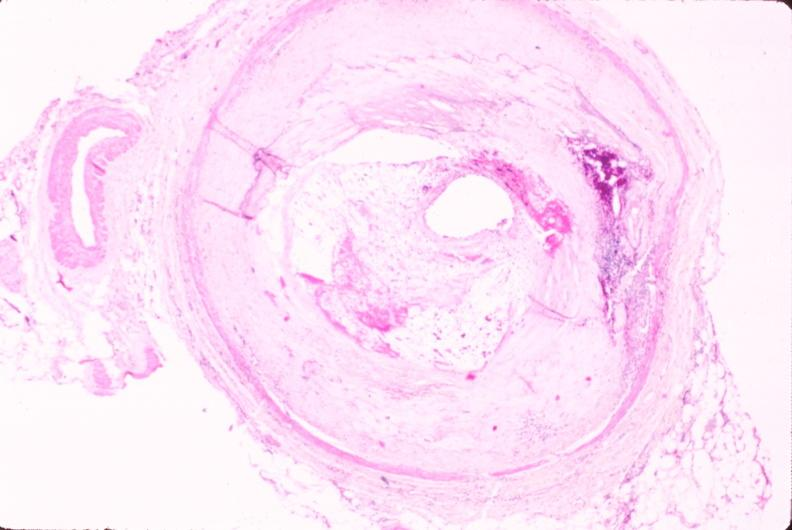how is atherosclerosis left anterior descending artery?
Answer the question using a single word or phrase. Coronary 